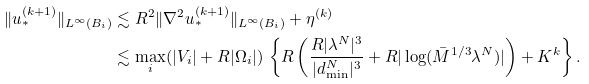<formula> <loc_0><loc_0><loc_500><loc_500>\| u _ { * } ^ { ( k + 1 ) } \| _ { L ^ { \infty } ( B _ { i } ) } & \lesssim R ^ { 2 } \| \nabla ^ { 2 } u _ { * } ^ { ( k + 1 ) } \| _ { L ^ { \infty } ( B _ { i } ) } + \eta ^ { ( k ) } \\ & \lesssim \underset { i } { \max } ( | V _ { i } | + R | \Omega _ { i } | ) \, \left \{ R \left ( \frac { R | \lambda ^ { N } | ^ { 3 } } { | d _ { \min } ^ { N } | ^ { 3 } } + R | \log ( \bar { M } ^ { 1 / 3 } \lambda ^ { N } ) | \right ) + K ^ { k } \right \} .</formula> 